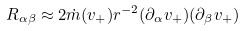<formula> <loc_0><loc_0><loc_500><loc_500>R _ { \alpha \beta } \approx 2 \dot { m } ( v _ { + } ) r ^ { - 2 } ( \partial _ { \alpha } v _ { + } ) ( \partial _ { \beta } v _ { + } )</formula> 